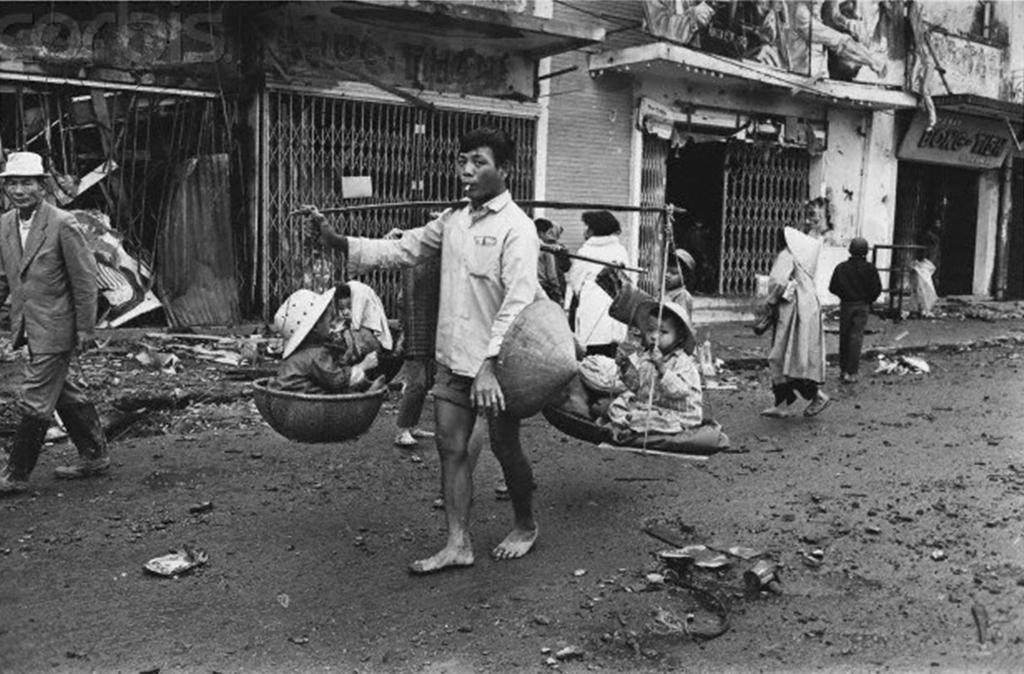What are the people in the image wearing? The persons in the image are wearing clothes. What can be seen in the middle of the image? There are buildings in the middle of the image. What is the person carrying in the image? The person is carrying babies with a stick in the image. What type of corn can be seen growing in the image? There is no corn present in the image. What kind of print can be seen on the buildings in the image? The provided facts do not mention any specific print on the buildings. 